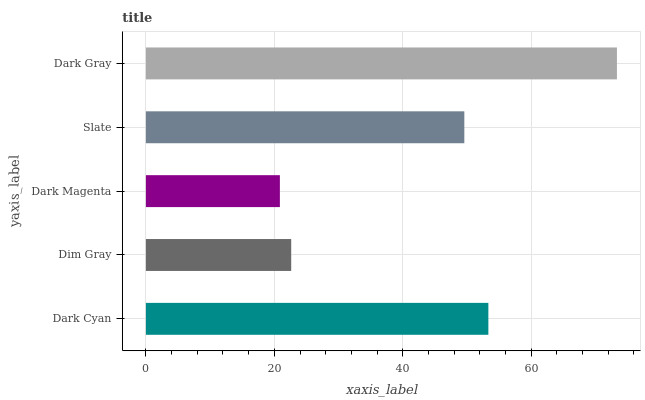Is Dark Magenta the minimum?
Answer yes or no. Yes. Is Dark Gray the maximum?
Answer yes or no. Yes. Is Dim Gray the minimum?
Answer yes or no. No. Is Dim Gray the maximum?
Answer yes or no. No. Is Dark Cyan greater than Dim Gray?
Answer yes or no. Yes. Is Dim Gray less than Dark Cyan?
Answer yes or no. Yes. Is Dim Gray greater than Dark Cyan?
Answer yes or no. No. Is Dark Cyan less than Dim Gray?
Answer yes or no. No. Is Slate the high median?
Answer yes or no. Yes. Is Slate the low median?
Answer yes or no. Yes. Is Dark Magenta the high median?
Answer yes or no. No. Is Dark Cyan the low median?
Answer yes or no. No. 